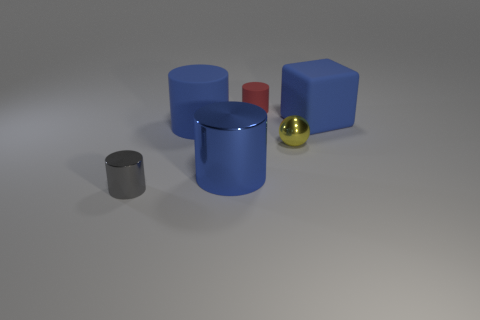Add 4 big objects. How many objects exist? 10 Add 6 small red objects. How many small red objects are left? 7 Add 3 large rubber things. How many large rubber things exist? 5 Subtract all red cylinders. How many cylinders are left? 3 Subtract all big matte cylinders. How many cylinders are left? 3 Subtract 1 yellow spheres. How many objects are left? 5 Subtract all cylinders. How many objects are left? 2 Subtract 1 balls. How many balls are left? 0 Subtract all gray blocks. Subtract all yellow balls. How many blocks are left? 1 Subtract all gray cubes. How many green cylinders are left? 0 